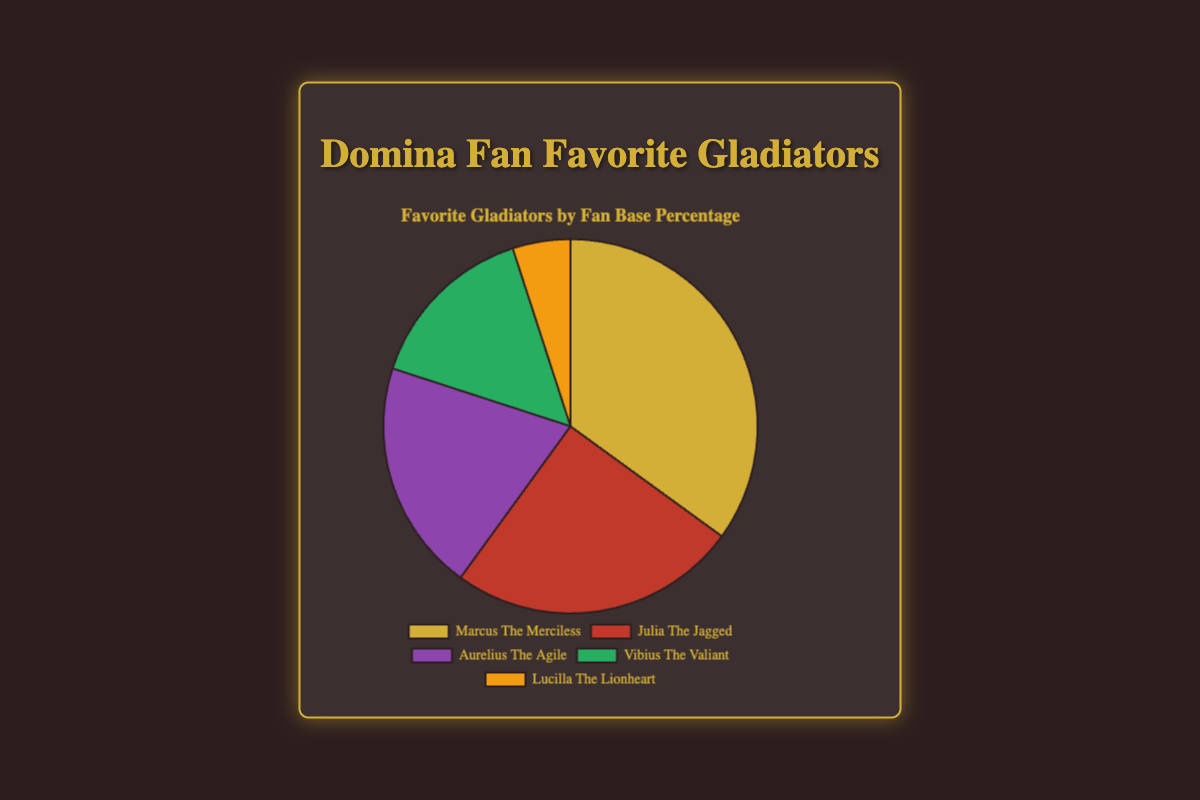which gladiator has the highest fan base percentage? The pie chart shows that Marcus The Merciless has the largest portion of the chart, indicating he has the highest fan base percentage.
Answer: Marcus The Merciless which two gladiators together comprise exactly a quarter of the fan base? Lucilla The Lionheart (5%) and Vibius The Valiant (15%) together make 20%, which is not a quarter. However, Julia The Jagged (25%) alone precisely makes up a quarter of the fan base.
Answer: Julia The Jagged how much more popular is Marcus The Merciless compared to Lucilla The Lionheart? Marcus The Merciless has 35% of the fan base, while Lucilla The Lionheart has 5%. The difference between them is 35% - 5% = 30%.
Answer: 30% which gladiator has the smallest fan base percentage, and what is that percentage? The pie chart indicates that the smallest portion belongs to Lucilla The Lionheart, which is labeled as 5%.
Answer: Lucilla The Lionheart, 5% Who has fewer fans, Aurelius The Agile or Vibius The Valiant? According to the pie chart, Aurelius The Agile has 20% and Vibius The Valiant has 15%. Therefore, Vibius The Valiant has fewer fans.
Answer: Vibius The Valiant which two gladiators combined have a higher percentage than Marcus The Merciless? Julia The Jagged (25%) and Aurelius The Agile (20%) combined make 25% + 20% = 45%, which is indeed higher than Marcus The Merciless's 35%.
Answer: Julia The Jagged and Aurelius The Agile What is the total fan base percentage for the three most popular gladiators? The three most popular gladiators are Marcus The Merciless (35%), Julia The Jagged (25%), and Aurelius The Agile (20%). Their combined percentage is 35% + 25% + 20% = 80%.
Answer: 80% which gladiator is represented by the red segment and what is their fan base percentage? The pie chart uses color to represent the different gladiators, and the red segment represents Julia The Jagged. The chart shows she has 25% of the fan base.
Answer: Julia The Jagged, 25% What is the combined percentage of fans preferring neither Marcus The Merciless nor Julia The Jagged? Fans of Marcus The Merciless and Julia The Jagged make up 35% + 25% = 60%. Therefore, the percentage for the others is 100% - 60% = 40%.
Answer: 40% What is the difference in the fan base percentage between Aurelius The Agile and Julia The Jagged? Julia The Jagged has 25% and Aurelius The Agile has 20%. The difference in their fan base percentage is 25% - 20% = 5%.
Answer: 5% 